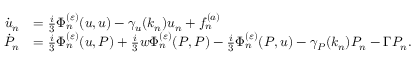Convert formula to latex. <formula><loc_0><loc_0><loc_500><loc_500>\begin{array} { r l } { \dot { u } _ { n } } & { = \frac { i } { 3 } \Phi _ { n } ^ { ( \varepsilon ) } ( u , u ) - \gamma _ { u } ( k _ { n } ) u _ { n } + f _ { n } ^ { ( a ) } } \\ { \dot { P } _ { n } } & { = \frac { i } { 3 } \Phi _ { n } ^ { ( \varepsilon ) } ( u , P ) + \frac { i } { 3 } w \Phi _ { n } ^ { ( \varepsilon ) } ( P , P ) - \frac { i } { 3 } \Phi _ { n } ^ { ( \varepsilon ) } ( P , u ) - \gamma _ { P } ( k _ { n } ) P _ { n } - \Gamma P _ { n } . } \end{array}</formula> 